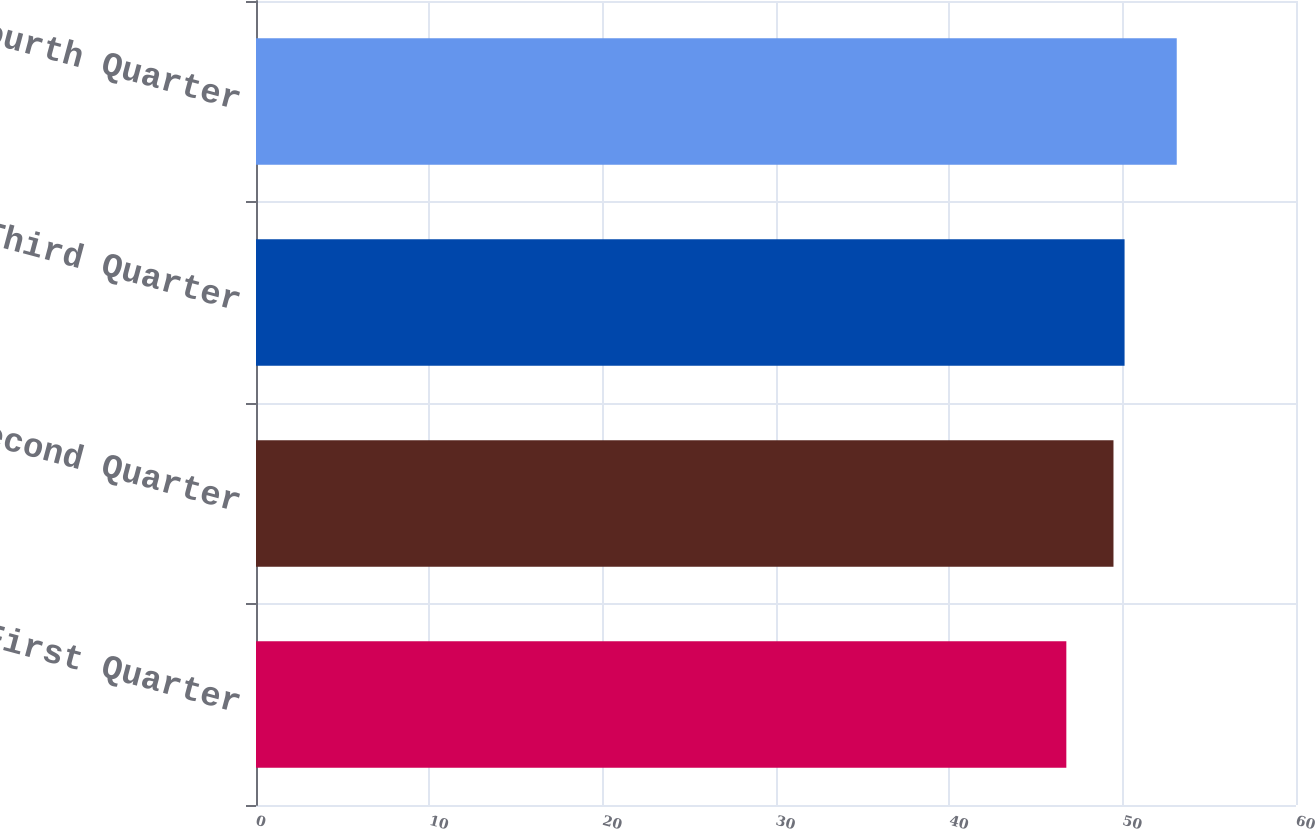Convert chart. <chart><loc_0><loc_0><loc_500><loc_500><bar_chart><fcel>First Quarter<fcel>Second Quarter<fcel>Third Quarter<fcel>Fourth Quarter<nl><fcel>46.75<fcel>49.47<fcel>50.11<fcel>53.12<nl></chart> 